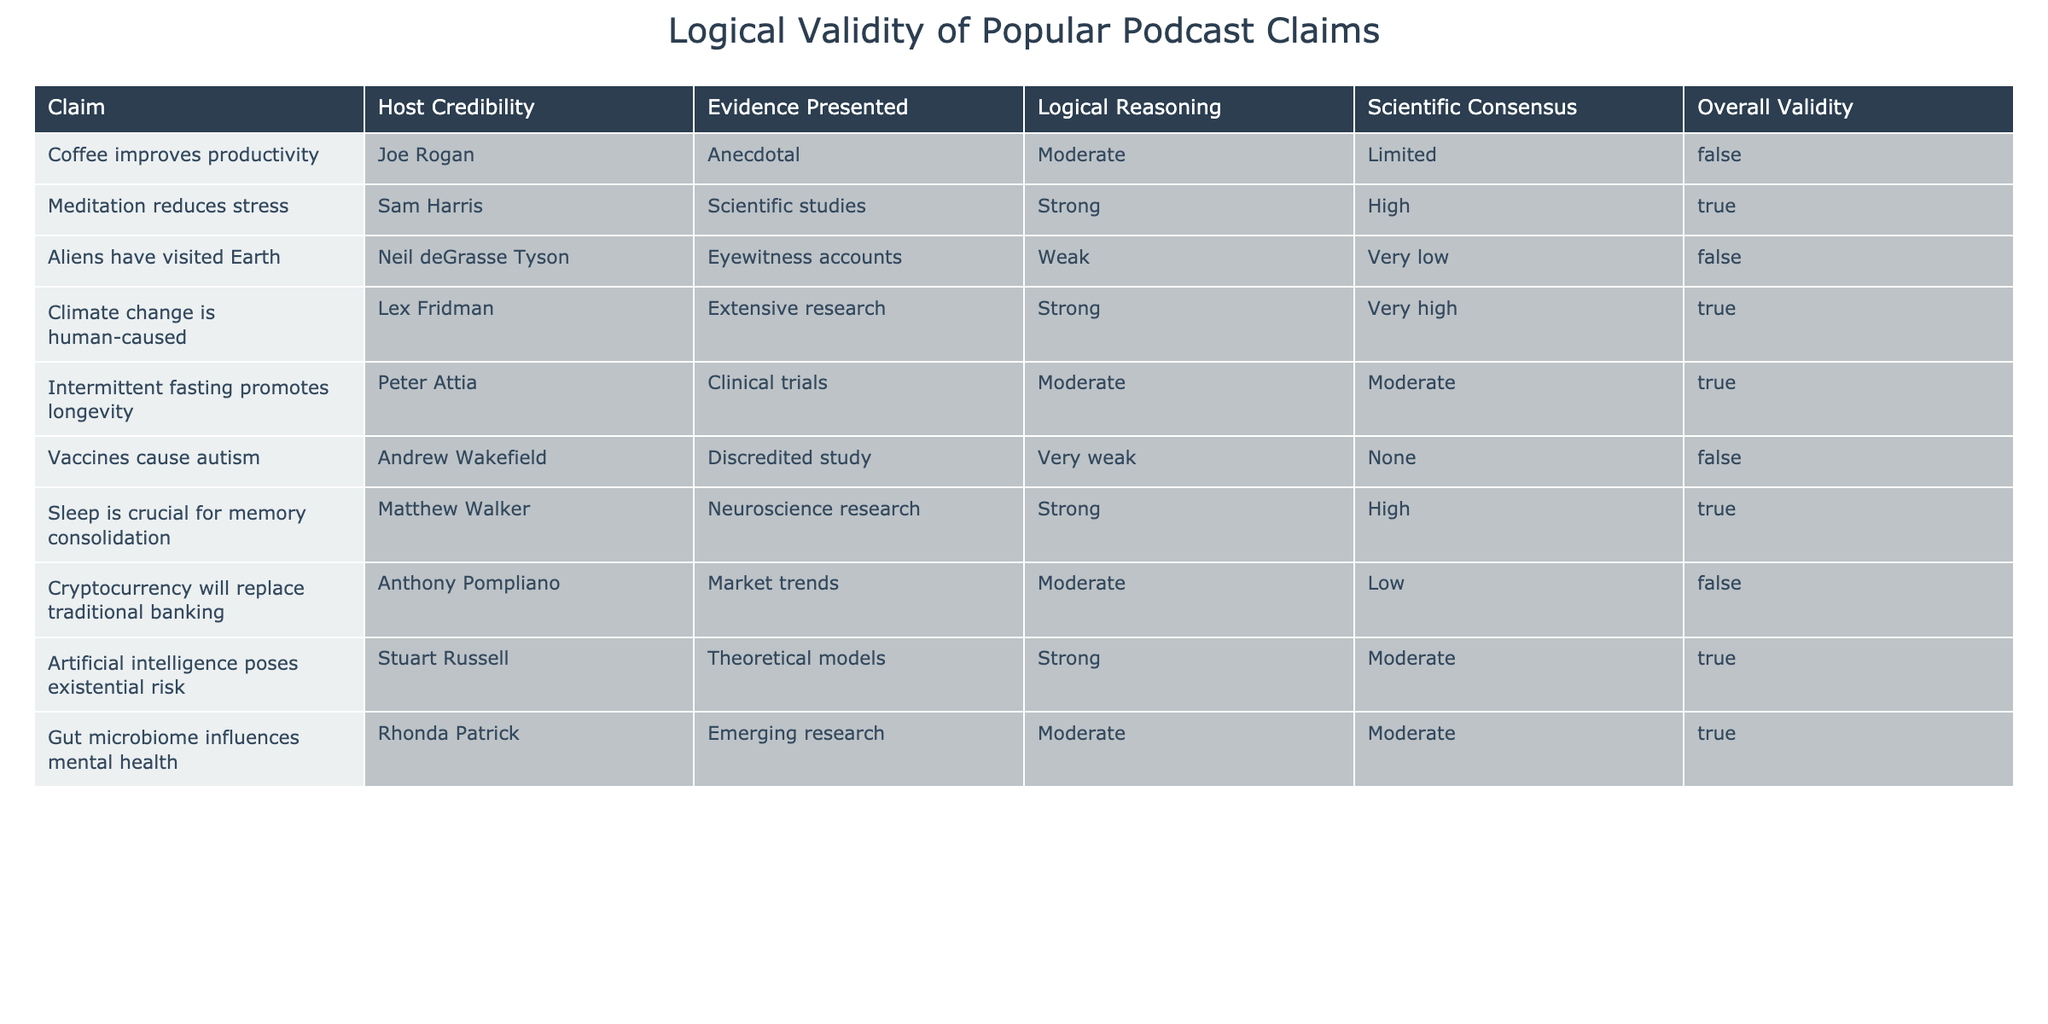What is the claim about coffee's effect on productivity? The table shows that the claim regarding coffee improving productivity is attributed to Joe Rogan, and it is described as anecdotal evidence with moderate credibility.
Answer: Coffee improves productivity How many claims in the table are considered valid? The table indicates that there are 3 claims with overall validity marked as True: "Meditation reduces stress," "Climate change is human-caused," "Sleep is crucial for memory consolidation," "Intermittent fasting promotes longevity," "Gut microbiome influences mental health," and "Artificial intelligence poses existential risk." A count of these gives us 6 valid claims.
Answer: 6 Which podcast claim has the strongest scientific consensus? Looking at the "Scientific Consensus" column, the claim "Climate change is human-caused" has the highest rating of "Very high." Therefore, it has the strongest scientific consensus among all the claims.
Answer: Climate change is human-caused Is there a claim that both has moderate host credibility and moderate evidence presented? The claim "Intermittent fasting promotes longevity" has moderate host credibility and moderate evidence, satisfying both conditions.
Answer: Yes What is the average level of logical reasoning for claims rated as true? To find this, we first identify the claims that are true: "Meditation reduces stress," "Climate change is human-caused," "Sleep is crucial for memory consolidation," "Intermittent fasting promotes longevity," "Gut microbiome influences mental health," and "Artificial intelligence poses existential risk." Their corresponding ratings for logical reasoning are: Strong, Strong, Strong, Moderate, Moderate, and Strong. On a scale where Strong = 3, Moderate = 2, and Weak = 1, we calculate the average: (3+3+3+2+2+3) / 6 = 2.67, which is approximately Moderate.
Answer: Moderate 